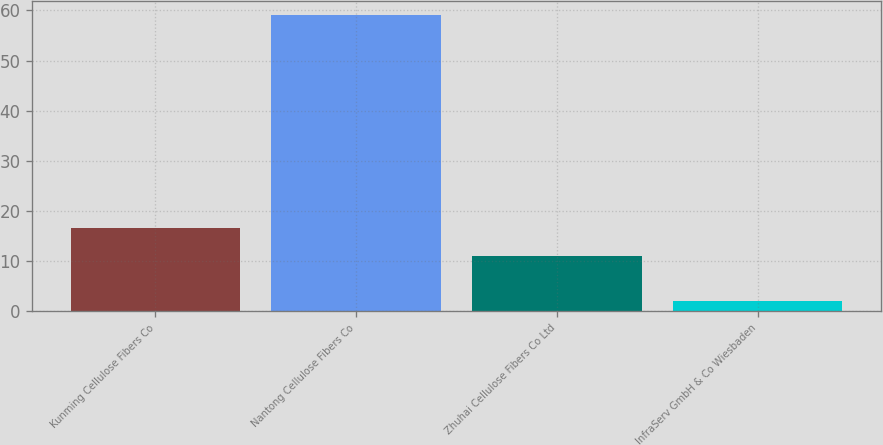Convert chart to OTSL. <chart><loc_0><loc_0><loc_500><loc_500><bar_chart><fcel>Kunming Cellulose Fibers Co<fcel>Nantong Cellulose Fibers Co<fcel>Zhuhai Cellulose Fibers Co Ltd<fcel>InfraServ GmbH & Co Wiesbaden<nl><fcel>16.7<fcel>59<fcel>11<fcel>2<nl></chart> 